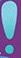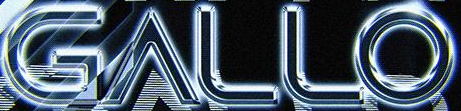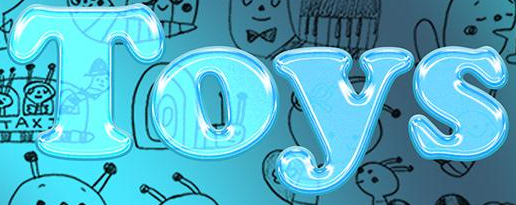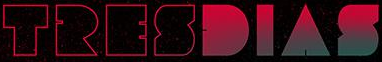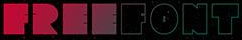What text appears in these images from left to right, separated by a semicolon? !; GALLO; Toys; TRESDIAS; FREEFONT 